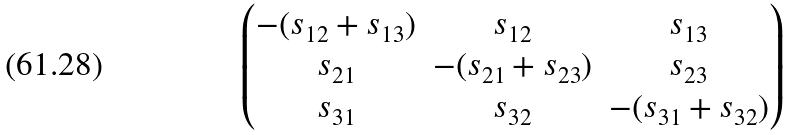Convert formula to latex. <formula><loc_0><loc_0><loc_500><loc_500>\begin{pmatrix} - ( s _ { 1 2 } + s _ { 1 3 } ) & s _ { 1 2 } & s _ { 1 3 } \\ s _ { 2 1 } & - ( s _ { 2 1 } + s _ { 2 3 } ) & s _ { 2 3 } \\ s _ { 3 1 } & s _ { 3 2 } & - ( s _ { 3 1 } + s _ { 3 2 } ) \end{pmatrix}</formula> 